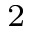Convert formula to latex. <formula><loc_0><loc_0><loc_500><loc_500>^ { 2 }</formula> 